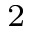Convert formula to latex. <formula><loc_0><loc_0><loc_500><loc_500>^ { 2 }</formula> 